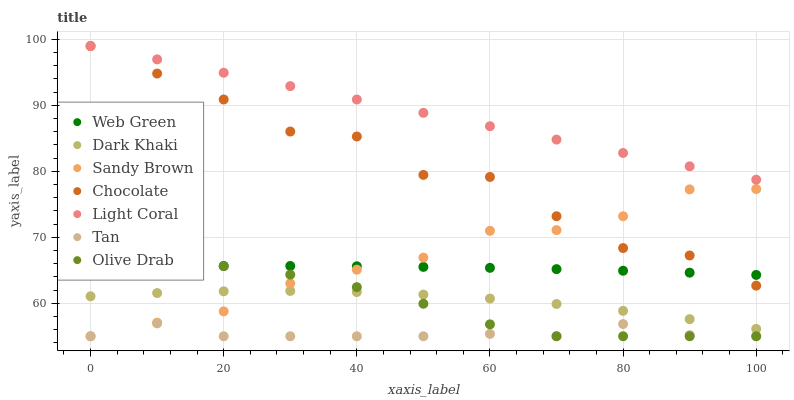Does Tan have the minimum area under the curve?
Answer yes or no. Yes. Does Light Coral have the maximum area under the curve?
Answer yes or no. Yes. Does Web Green have the minimum area under the curve?
Answer yes or no. No. Does Web Green have the maximum area under the curve?
Answer yes or no. No. Is Light Coral the smoothest?
Answer yes or no. Yes. Is Chocolate the roughest?
Answer yes or no. Yes. Is Web Green the smoothest?
Answer yes or no. No. Is Web Green the roughest?
Answer yes or no. No. Does Tan have the lowest value?
Answer yes or no. Yes. Does Web Green have the lowest value?
Answer yes or no. No. Does Chocolate have the highest value?
Answer yes or no. Yes. Does Web Green have the highest value?
Answer yes or no. No. Is Sandy Brown less than Light Coral?
Answer yes or no. Yes. Is Dark Khaki greater than Tan?
Answer yes or no. Yes. Does Sandy Brown intersect Tan?
Answer yes or no. Yes. Is Sandy Brown less than Tan?
Answer yes or no. No. Is Sandy Brown greater than Tan?
Answer yes or no. No. Does Sandy Brown intersect Light Coral?
Answer yes or no. No. 